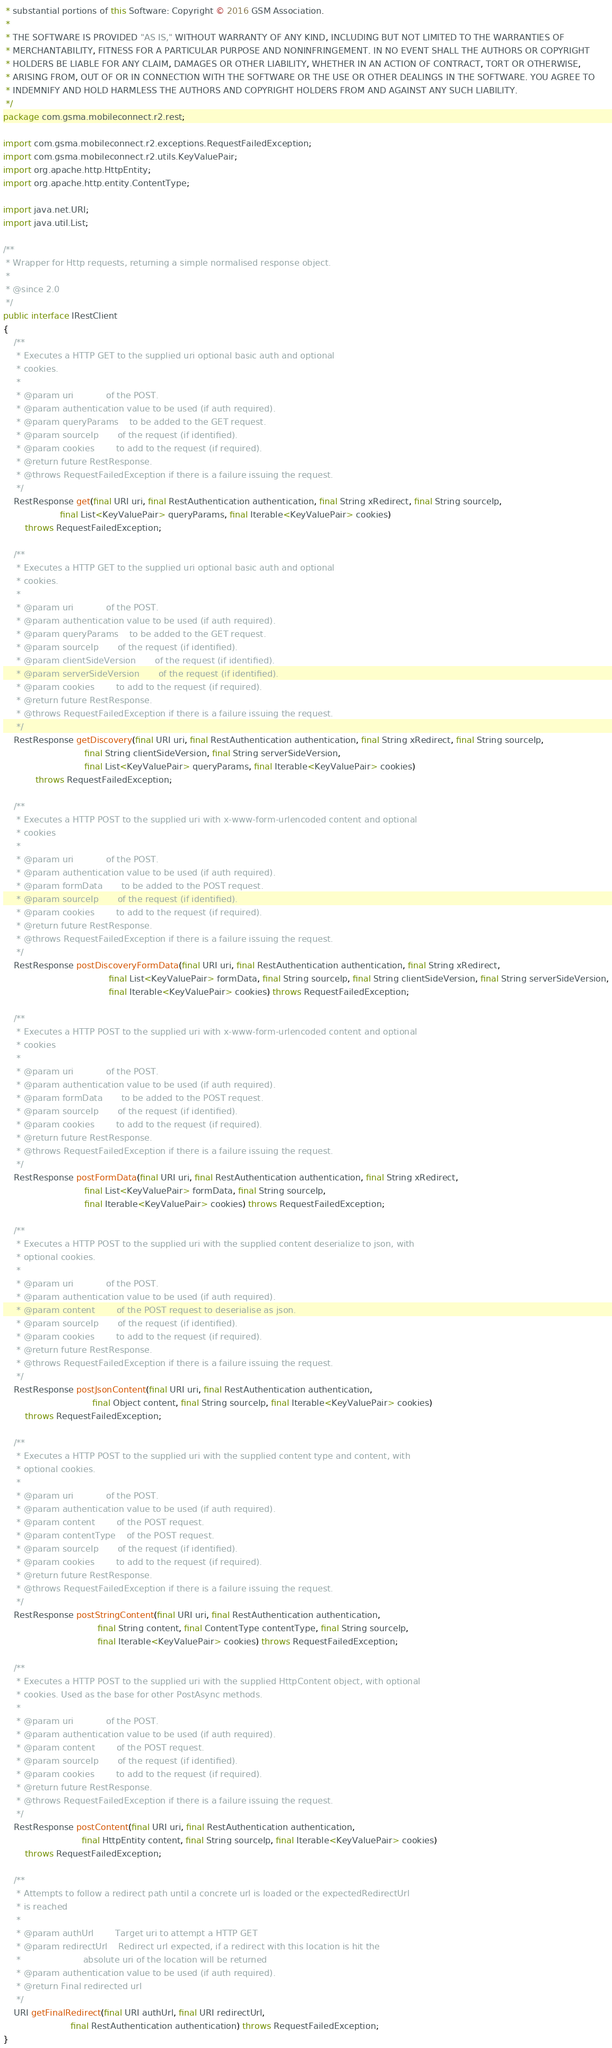<code> <loc_0><loc_0><loc_500><loc_500><_Java_> * substantial portions of this Software: Copyright © 2016 GSM Association.
 *
 * THE SOFTWARE IS PROVIDED "AS IS," WITHOUT WARRANTY OF ANY KIND, INCLUDING BUT NOT LIMITED TO THE WARRANTIES OF
 * MERCHANTABILITY, FITNESS FOR A PARTICULAR PURPOSE AND NONINFRINGEMENT. IN NO EVENT SHALL THE AUTHORS OR COPYRIGHT
 * HOLDERS BE LIABLE FOR ANY CLAIM, DAMAGES OR OTHER LIABILITY, WHETHER IN AN ACTION OF CONTRACT, TORT OR OTHERWISE,
 * ARISING FROM, OUT OF OR IN CONNECTION WITH THE SOFTWARE OR THE USE OR OTHER DEALINGS IN THE SOFTWARE. YOU AGREE TO
 * INDEMNIFY AND HOLD HARMLESS THE AUTHORS AND COPYRIGHT HOLDERS FROM AND AGAINST ANY SUCH LIABILITY.
 */
package com.gsma.mobileconnect.r2.rest;

import com.gsma.mobileconnect.r2.exceptions.RequestFailedException;
import com.gsma.mobileconnect.r2.utils.KeyValuePair;
import org.apache.http.HttpEntity;
import org.apache.http.entity.ContentType;

import java.net.URI;
import java.util.List;

/**
 * Wrapper for Http requests, returning a simple normalised response object.
 *
 * @since 2.0
 */
public interface IRestClient
{
    /**
     * Executes a HTTP GET to the supplied uri optional basic auth and optional
     * cookies.
     *
     * @param uri            of the POST.
     * @param authentication value to be used (if auth required).
     * @param queryParams    to be added to the GET request.
     * @param sourceIp       of the request (if identified).
     * @param cookies        to add to the request (if required).
     * @return future RestResponse.
     * @throws RequestFailedException if there is a failure issuing the request.
     */
    RestResponse get(final URI uri, final RestAuthentication authentication, final String xRedirect, final String sourceIp,
                     final List<KeyValuePair> queryParams, final Iterable<KeyValuePair> cookies)
        throws RequestFailedException;

    /**
     * Executes a HTTP GET to the supplied uri optional basic auth and optional
     * cookies.
     *
     * @param uri            of the POST.
     * @param authentication value to be used (if auth required).
     * @param queryParams    to be added to the GET request.
     * @param sourceIp       of the request (if identified).
     * @param clientSideVersion       of the request (if identified).
     * @param serverSideVersion       of the request (if identified).
     * @param cookies        to add to the request (if required).
     * @return future RestResponse.
     * @throws RequestFailedException if there is a failure issuing the request.
     */
    RestResponse getDiscovery(final URI uri, final RestAuthentication authentication, final String xRedirect, final String sourceIp,
                              final String clientSideVersion, final String serverSideVersion,
                              final List<KeyValuePair> queryParams, final Iterable<KeyValuePair> cookies)
            throws RequestFailedException;

    /**
     * Executes a HTTP POST to the supplied uri with x-www-form-urlencoded content and optional
     * cookies
     *
     * @param uri            of the POST.
     * @param authentication value to be used (if auth required).
     * @param formData       to be added to the POST request.
     * @param sourceIp       of the request (if identified).
     * @param cookies        to add to the request (if required).
     * @return future RestResponse.
     * @throws RequestFailedException if there is a failure issuing the request.
     */
    RestResponse postDiscoveryFormData(final URI uri, final RestAuthentication authentication, final String xRedirect,
                                       final List<KeyValuePair> formData, final String sourceIp, final String clientSideVersion, final String serverSideVersion,
                                       final Iterable<KeyValuePair> cookies) throws RequestFailedException;

    /**
     * Executes a HTTP POST to the supplied uri with x-www-form-urlencoded content and optional
     * cookies
     *
     * @param uri            of the POST.
     * @param authentication value to be used (if auth required).
     * @param formData       to be added to the POST request.
     * @param sourceIp       of the request (if identified).
     * @param cookies        to add to the request (if required).
     * @return future RestResponse.
     * @throws RequestFailedException if there is a failure issuing the request.
     */
    RestResponse postFormData(final URI uri, final RestAuthentication authentication, final String xRedirect,
                              final List<KeyValuePair> formData, final String sourceIp,
                              final Iterable<KeyValuePair> cookies) throws RequestFailedException;

    /**
     * Executes a HTTP POST to the supplied uri with the supplied content deserialize to json, with
     * optional cookies.
     *
     * @param uri            of the POST.
     * @param authentication value to be used (if auth required).
     * @param content        of the POST request to deserialise as json.
     * @param sourceIp       of the request (if identified).
     * @param cookies        to add to the request (if required).
     * @return future RestResponse.
     * @throws RequestFailedException if there is a failure issuing the request.
     */
    RestResponse postJsonContent(final URI uri, final RestAuthentication authentication,
                                 final Object content, final String sourceIp, final Iterable<KeyValuePair> cookies)
        throws RequestFailedException;

    /**
     * Executes a HTTP POST to the supplied uri with the supplied content type and content, with
     * optional cookies.
     *
     * @param uri            of the POST.
     * @param authentication value to be used (if auth required).
     * @param content        of the POST request.
     * @param contentType    of the POST request.
     * @param sourceIp       of the request (if identified).
     * @param cookies        to add to the request (if required).
     * @return future RestResponse.
     * @throws RequestFailedException if there is a failure issuing the request.
     */
    RestResponse postStringContent(final URI uri, final RestAuthentication authentication,
                                   final String content, final ContentType contentType, final String sourceIp,
                                   final Iterable<KeyValuePair> cookies) throws RequestFailedException;

    /**
     * Executes a HTTP POST to the supplied uri with the supplied HttpContent object, with optional
     * cookies. Used as the base for other PostAsync methods.
     *
     * @param uri            of the POST.
     * @param authentication value to be used (if auth required).
     * @param content        of the POST request.
     * @param sourceIp       of the request (if identified).
     * @param cookies        to add to the request (if required).
     * @return future RestResponse.
     * @throws RequestFailedException if there is a failure issuing the request.
     */
    RestResponse postContent(final URI uri, final RestAuthentication authentication,
                             final HttpEntity content, final String sourceIp, final Iterable<KeyValuePair> cookies)
        throws RequestFailedException;

    /**
     * Attempts to follow a redirect path until a concrete url is loaded or the expectedRedirectUrl
     * is reached
     *
     * @param authUrl        Target uri to attempt a HTTP GET
     * @param redirectUrl    Redirect url expected, if a redirect with this location is hit the
     *                       absolute uri of the location will be returned
     * @param authentication value to be used (if auth required).
     * @return Final redirected url
     */
    URI getFinalRedirect(final URI authUrl, final URI redirectUrl,
                         final RestAuthentication authentication) throws RequestFailedException;
}
</code> 